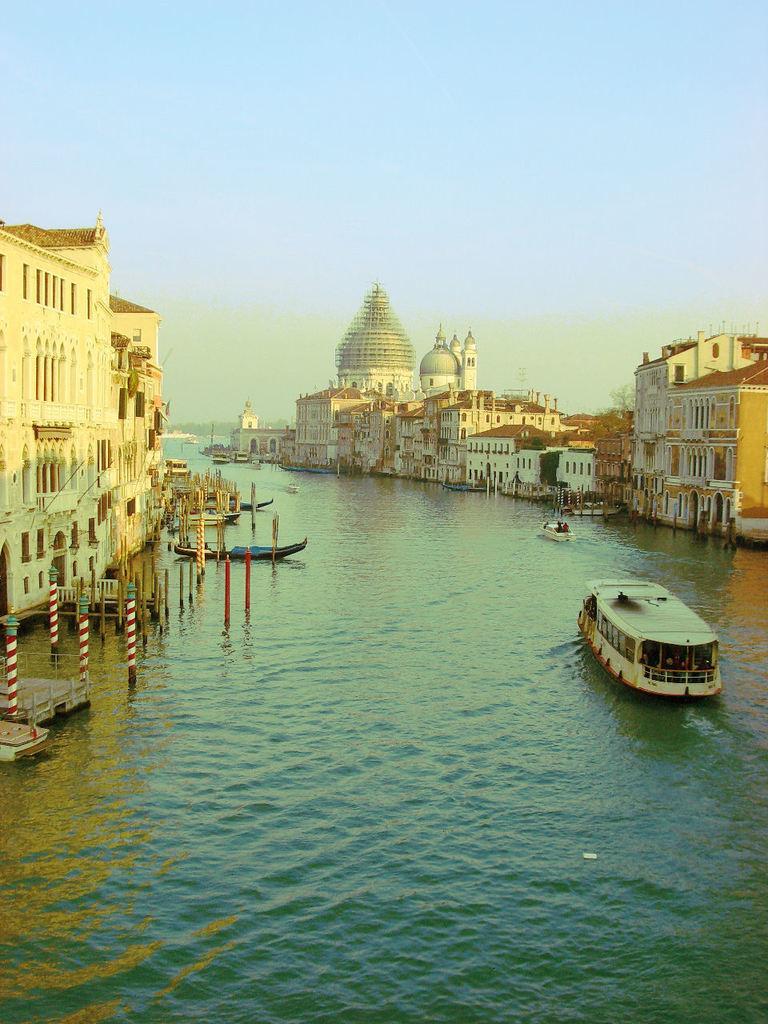Describe this image in one or two sentences. In this image on the right side we see a boat and the background is the sky and there are buildings on the left side. 